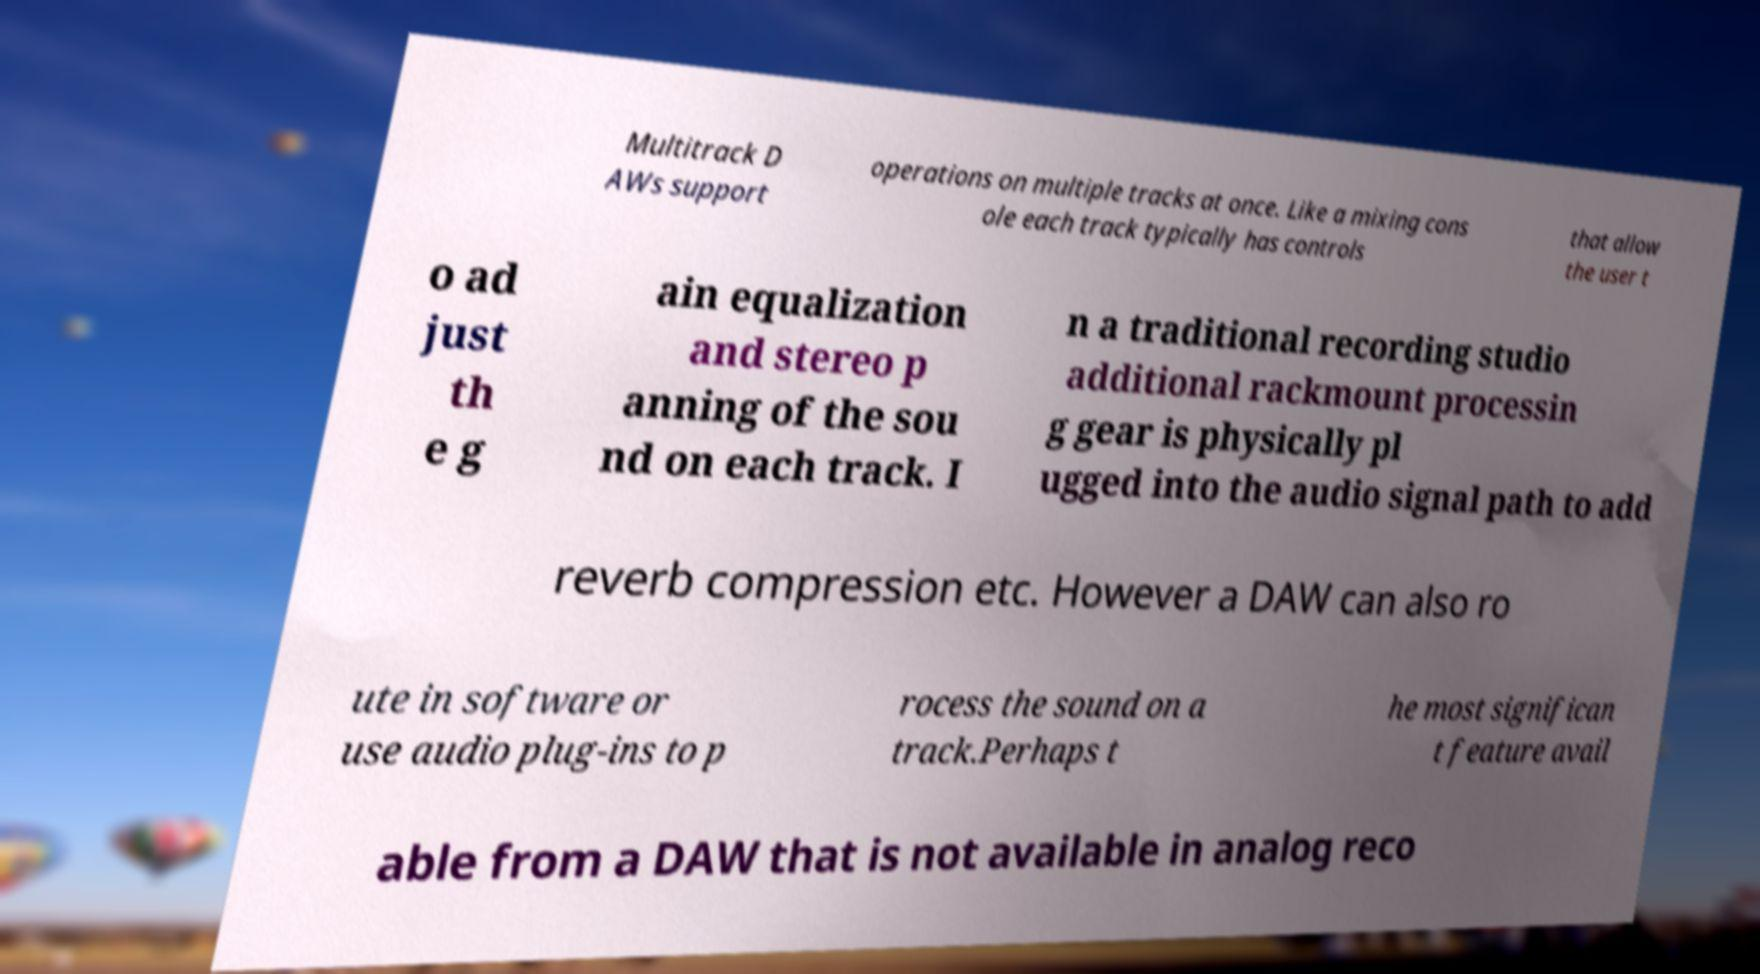Please read and relay the text visible in this image. What does it say? Multitrack D AWs support operations on multiple tracks at once. Like a mixing cons ole each track typically has controls that allow the user t o ad just th e g ain equalization and stereo p anning of the sou nd on each track. I n a traditional recording studio additional rackmount processin g gear is physically pl ugged into the audio signal path to add reverb compression etc. However a DAW can also ro ute in software or use audio plug-ins to p rocess the sound on a track.Perhaps t he most significan t feature avail able from a DAW that is not available in analog reco 